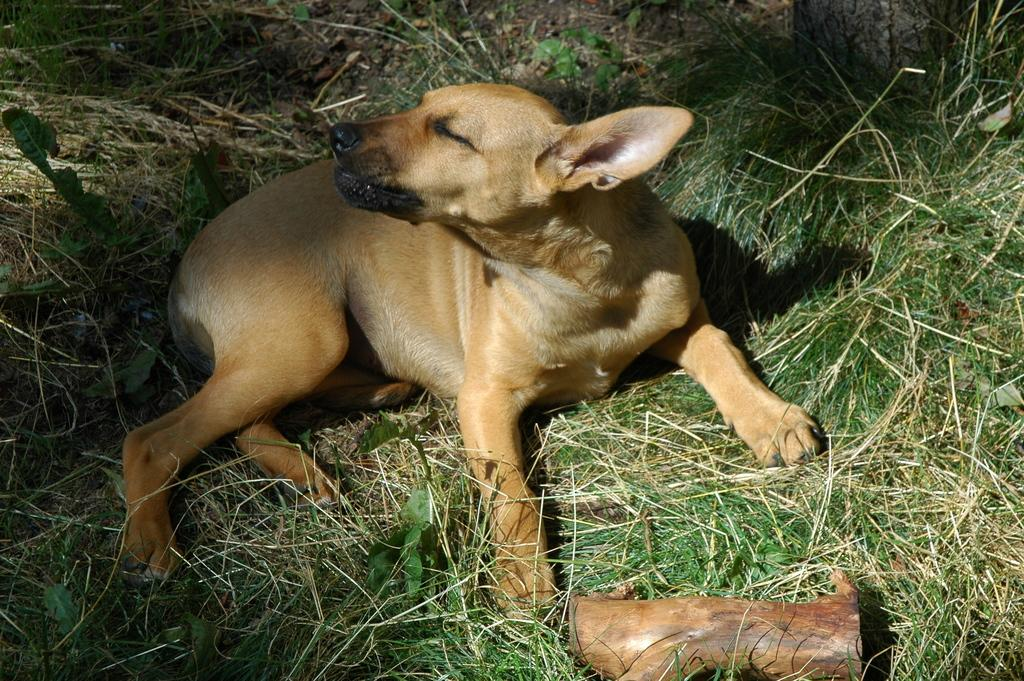What type of vegetation is present in the image? There is green grass in the image. What animal can be seen on the grass? There is a cream-colored dog on the grass. What is the color of the object in the image? There is a brown-colored object in the image. What type of quill is the dog using to write in the image? There is no quill present in the image, and the dog is not writing. 